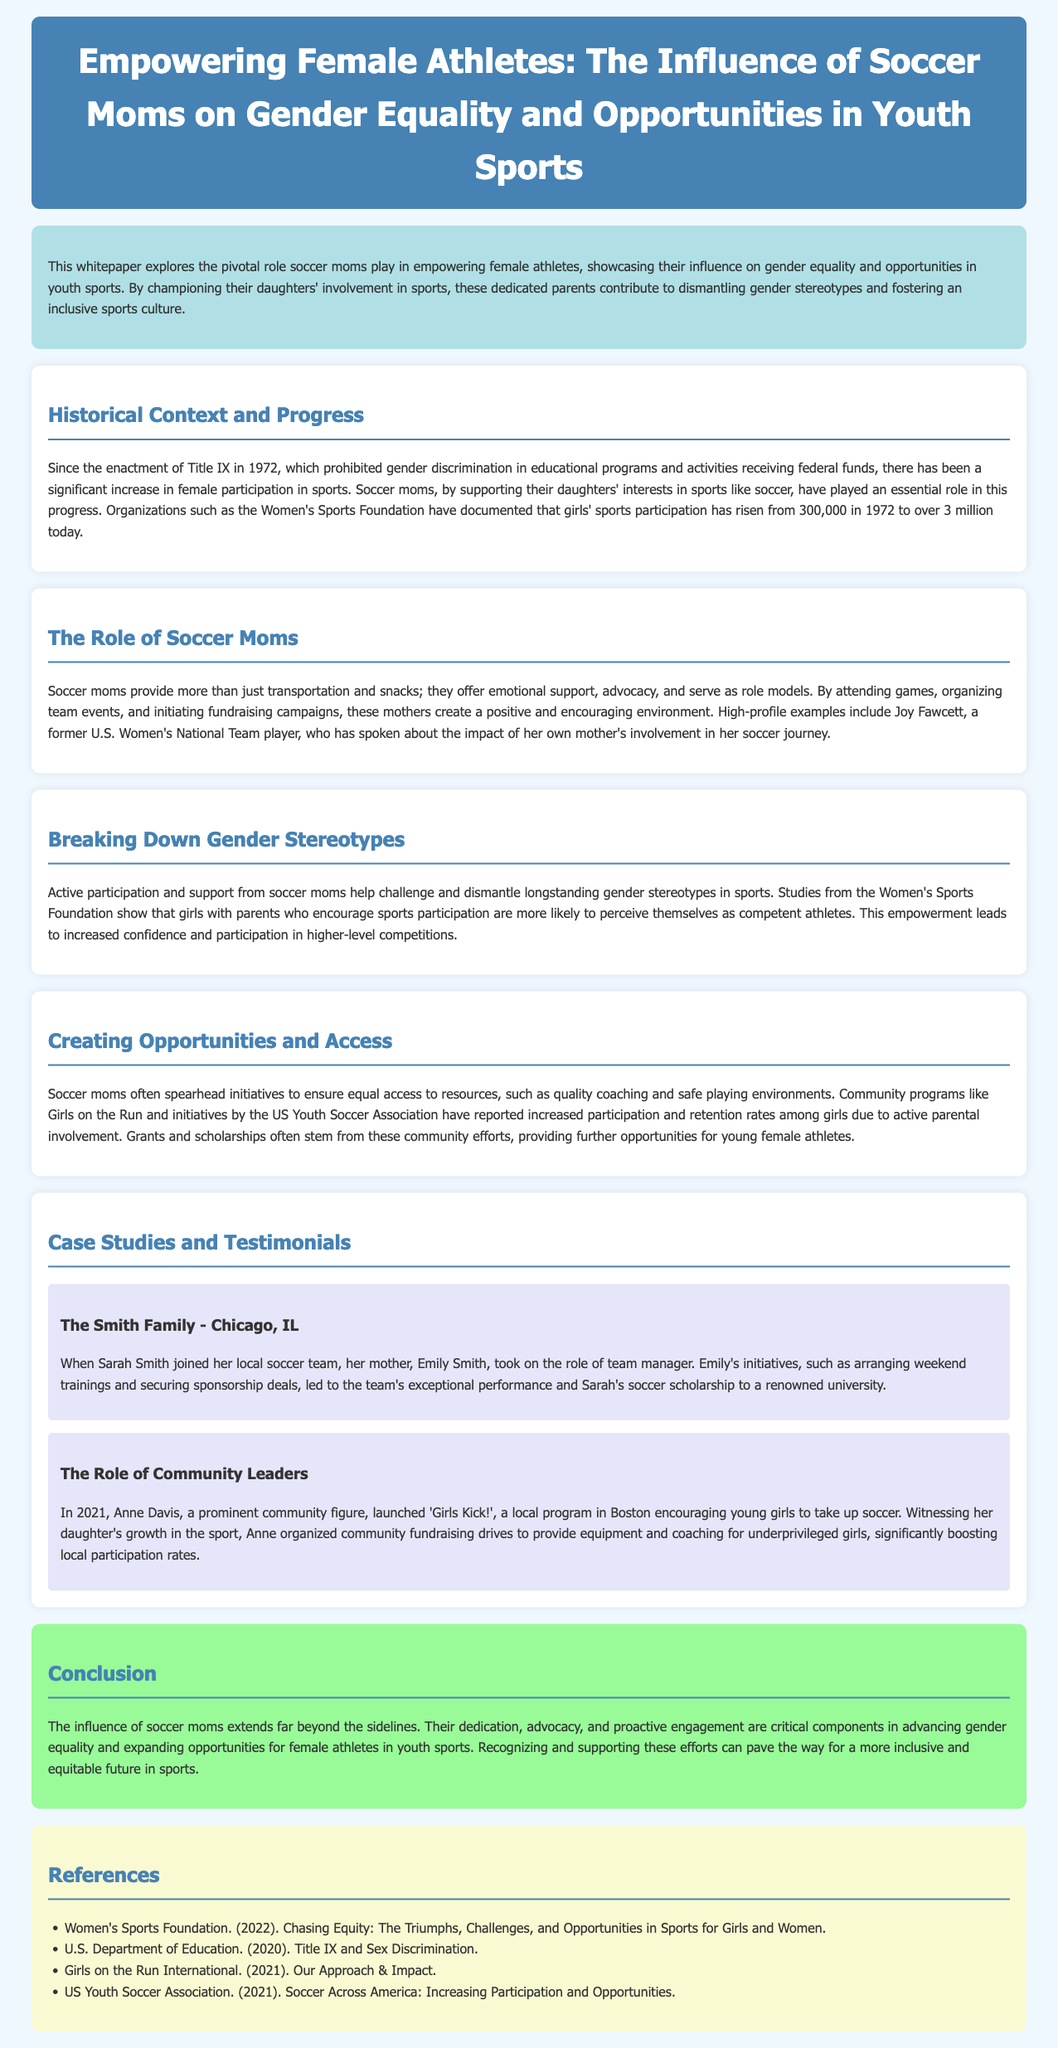What is the title of the whitepaper? The title is presented prominently in the header of the document.
Answer: Empowering Female Athletes: The Influence of Soccer Moms on Gender Equality and Opportunities in Youth Sports What year was Title IX enacted? This information is found in the historical context section.
Answer: 1972 How many girls participated in sports in 1972? The document specifies the number of participants in the historical context section.
Answer: 300,000 What community program encourages girls to take up soccer? This information can be found in the section about creating opportunities and access.
Answer: Girls on the Run Who is a high-profile example of a soccer mom mentioned? The role of Joy Fawcett is highlighted as an example in the relevant section.
Answer: Joy Fawcett What impact do soccer moms have on girls' perceptions according to studies? The effect on confidence and self-perception is discussed in the section about breaking down gender stereotypes.
Answer: Competent athletes What was the outcome for Sarah Smith due to her mother's involvement? This information is detailed in the case study of the Smith family.
Answer: Soccer scholarship to a renowned university Which city did Anne Davis launch 'Girls Kick!'? This information is found within the second case study in the document.
Answer: Boston 